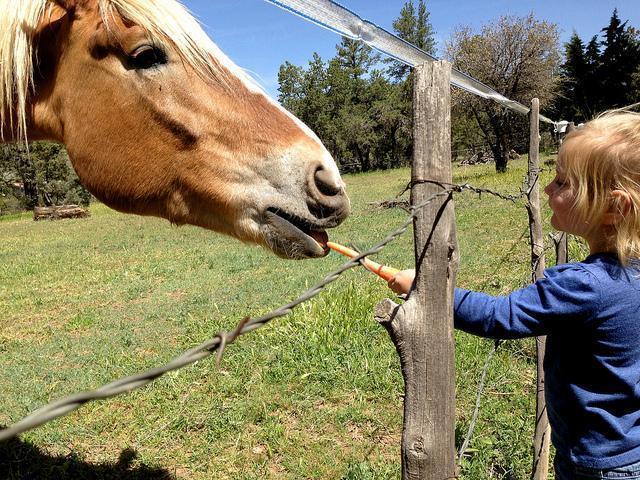What vegetable is toxic to horses?
From the following four choices, select the correct answer to address the question.
Options: Eggplant, carrot, tomatoes, beans. Tomatoes. 